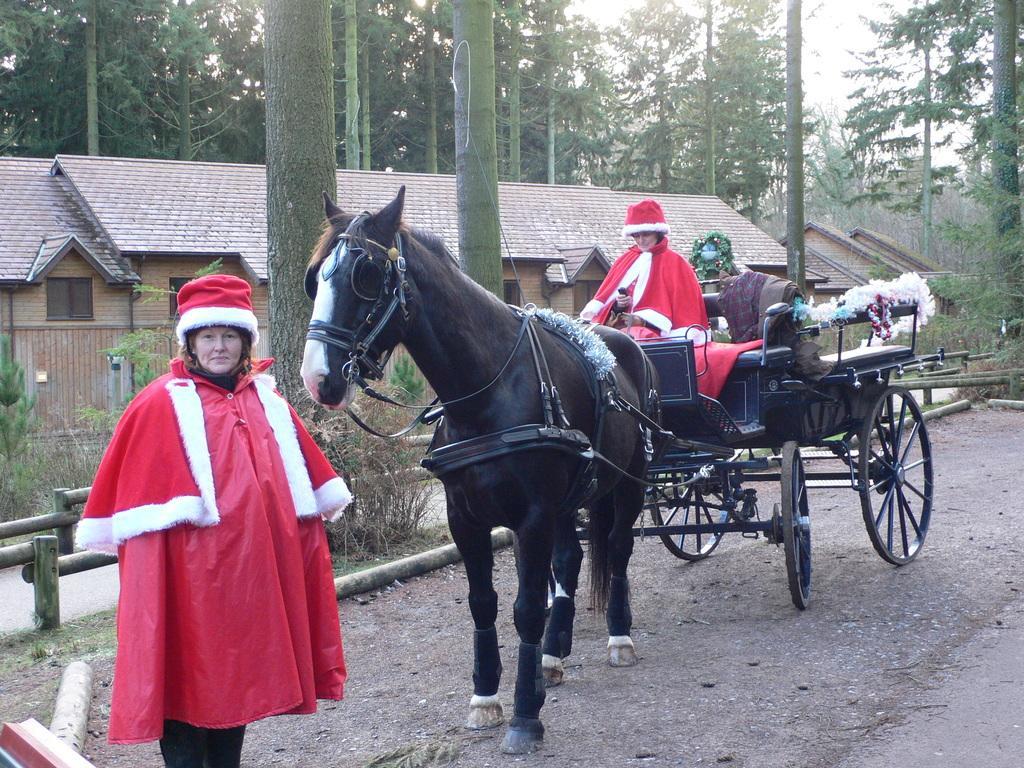Describe this image in one or two sentences. This picture is clicked outside. On the left we can see a person wearing red color dress and standing on the ground. On the right we can see another person holding some object and sitting in the chariot and we can see a horse standing on the ground. In the background we can see the sky, trees, houses, plants, grass and some other objects. 